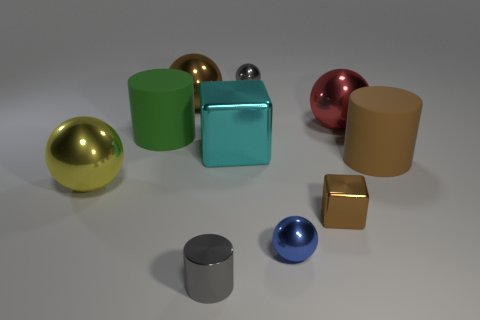How many objects are there of each color? In the image, there are nine objects with distinct colors: two gold, two green, one cyan, one brown, one pink, one blue, and one matte gray. 